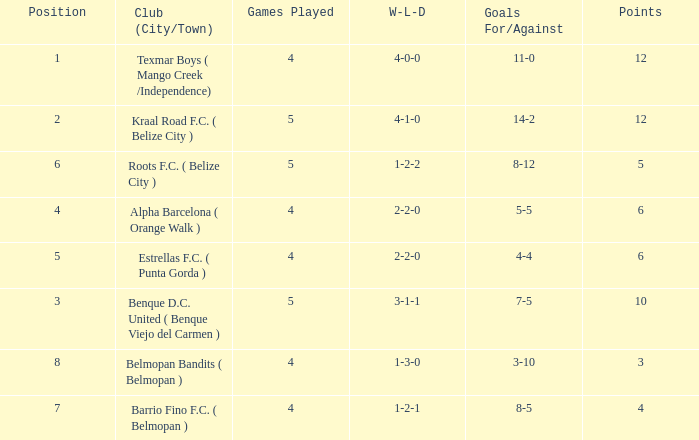Who is the the club (city/town) with goals for/against being 14-2 Kraal Road F.C. ( Belize City ). 